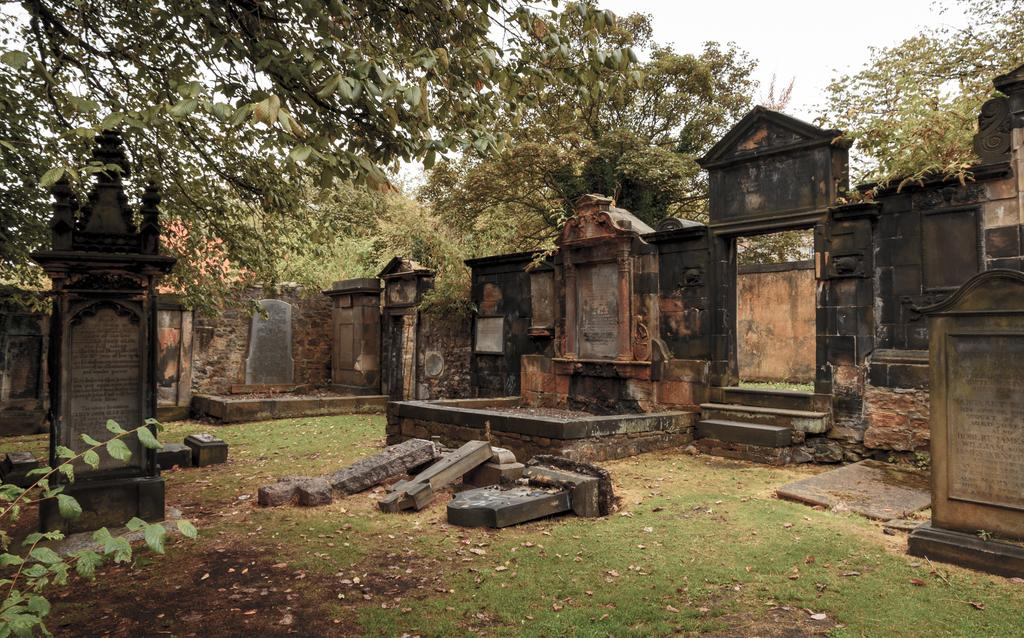What can be seen in the foreground of the image? In the foreground of the image, there are headstones, a wall, trees, and steps. What is visible in the background of the image? The sky is visible in the image. What type of trousers are hanging on the wall in the image? There are no trousers present in the image. How many times has the kettle been folded in the image? There is no kettle present in the image, so it cannot be folded or unfolded. 